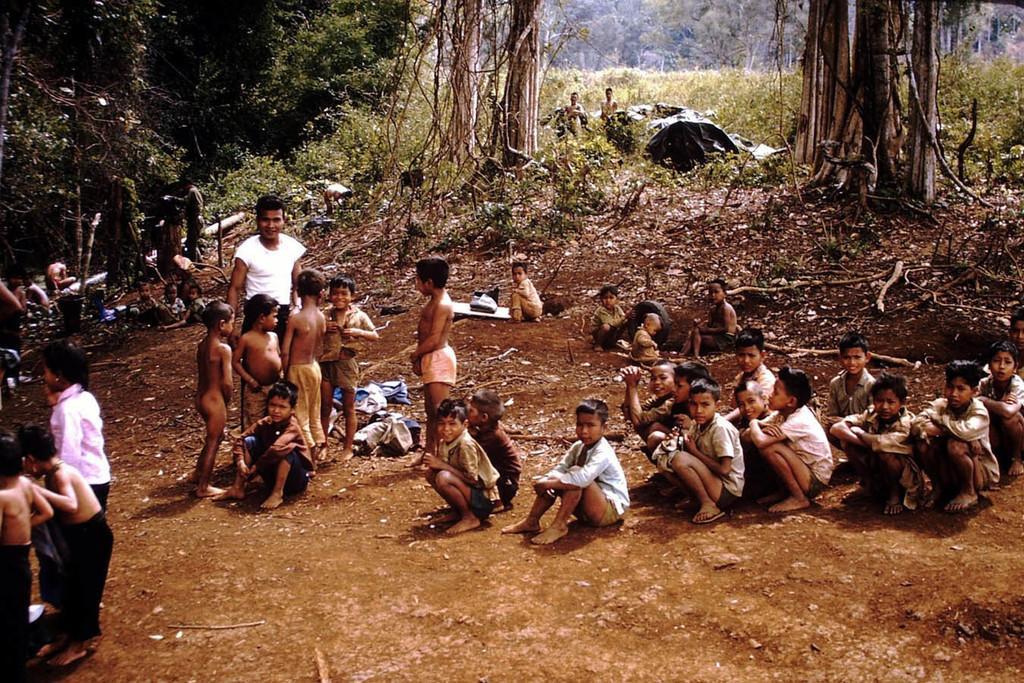Can you describe this image briefly? In the foreground of this image, there are persons sitting, standing and squatting on the ground. In the background, it seems like a shelter, two persons standing and the greenery. 